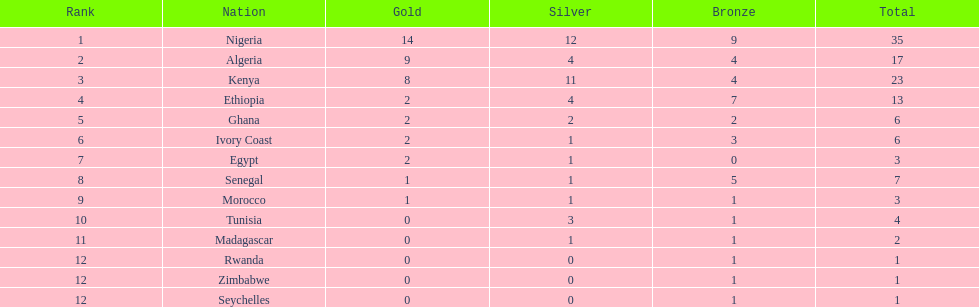In which country were the least amount of bronze medals won? Egypt. 